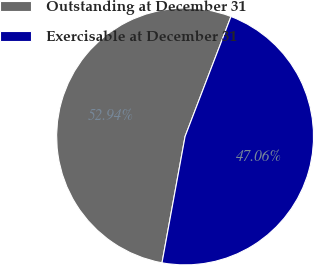Convert chart to OTSL. <chart><loc_0><loc_0><loc_500><loc_500><pie_chart><fcel>Outstanding at December 31<fcel>Exercisable at December 31<nl><fcel>52.94%<fcel>47.06%<nl></chart> 